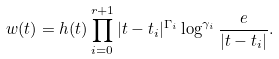Convert formula to latex. <formula><loc_0><loc_0><loc_500><loc_500>w ( t ) = h ( t ) \prod _ { i = 0 } ^ { r + 1 } | t - t _ { i } | ^ { \Gamma _ { i } } \log ^ { \gamma _ { i } } \frac { e } { | t - t _ { i } | } .</formula> 